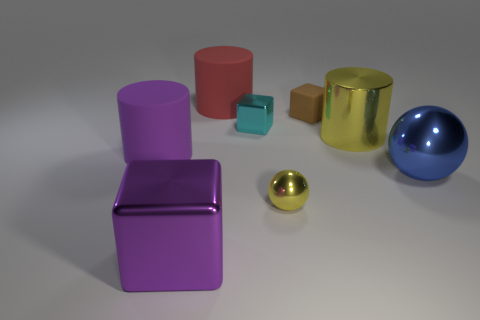How many other objects are there of the same material as the red cylinder?
Keep it short and to the point. 2. How many tiny objects are rubber cubes or brown shiny cylinders?
Keep it short and to the point. 1. Is the number of big rubber things to the left of the big purple metallic thing the same as the number of brown rubber things?
Your answer should be very brief. Yes. There is a block in front of the blue metal thing; are there any large metal cubes that are behind it?
Provide a short and direct response. No. What number of other things are there of the same color as the tiny metallic sphere?
Give a very brief answer. 1. The big metal cylinder has what color?
Your response must be concise. Yellow. There is a metal thing that is in front of the large yellow object and right of the tiny brown thing; how big is it?
Keep it short and to the point. Large. How many objects are either things that are right of the small brown matte block or large red cylinders?
Offer a terse response. 3. There is a small brown object that is the same material as the purple cylinder; what is its shape?
Offer a terse response. Cube. There is a big blue object; what shape is it?
Make the answer very short. Sphere. 